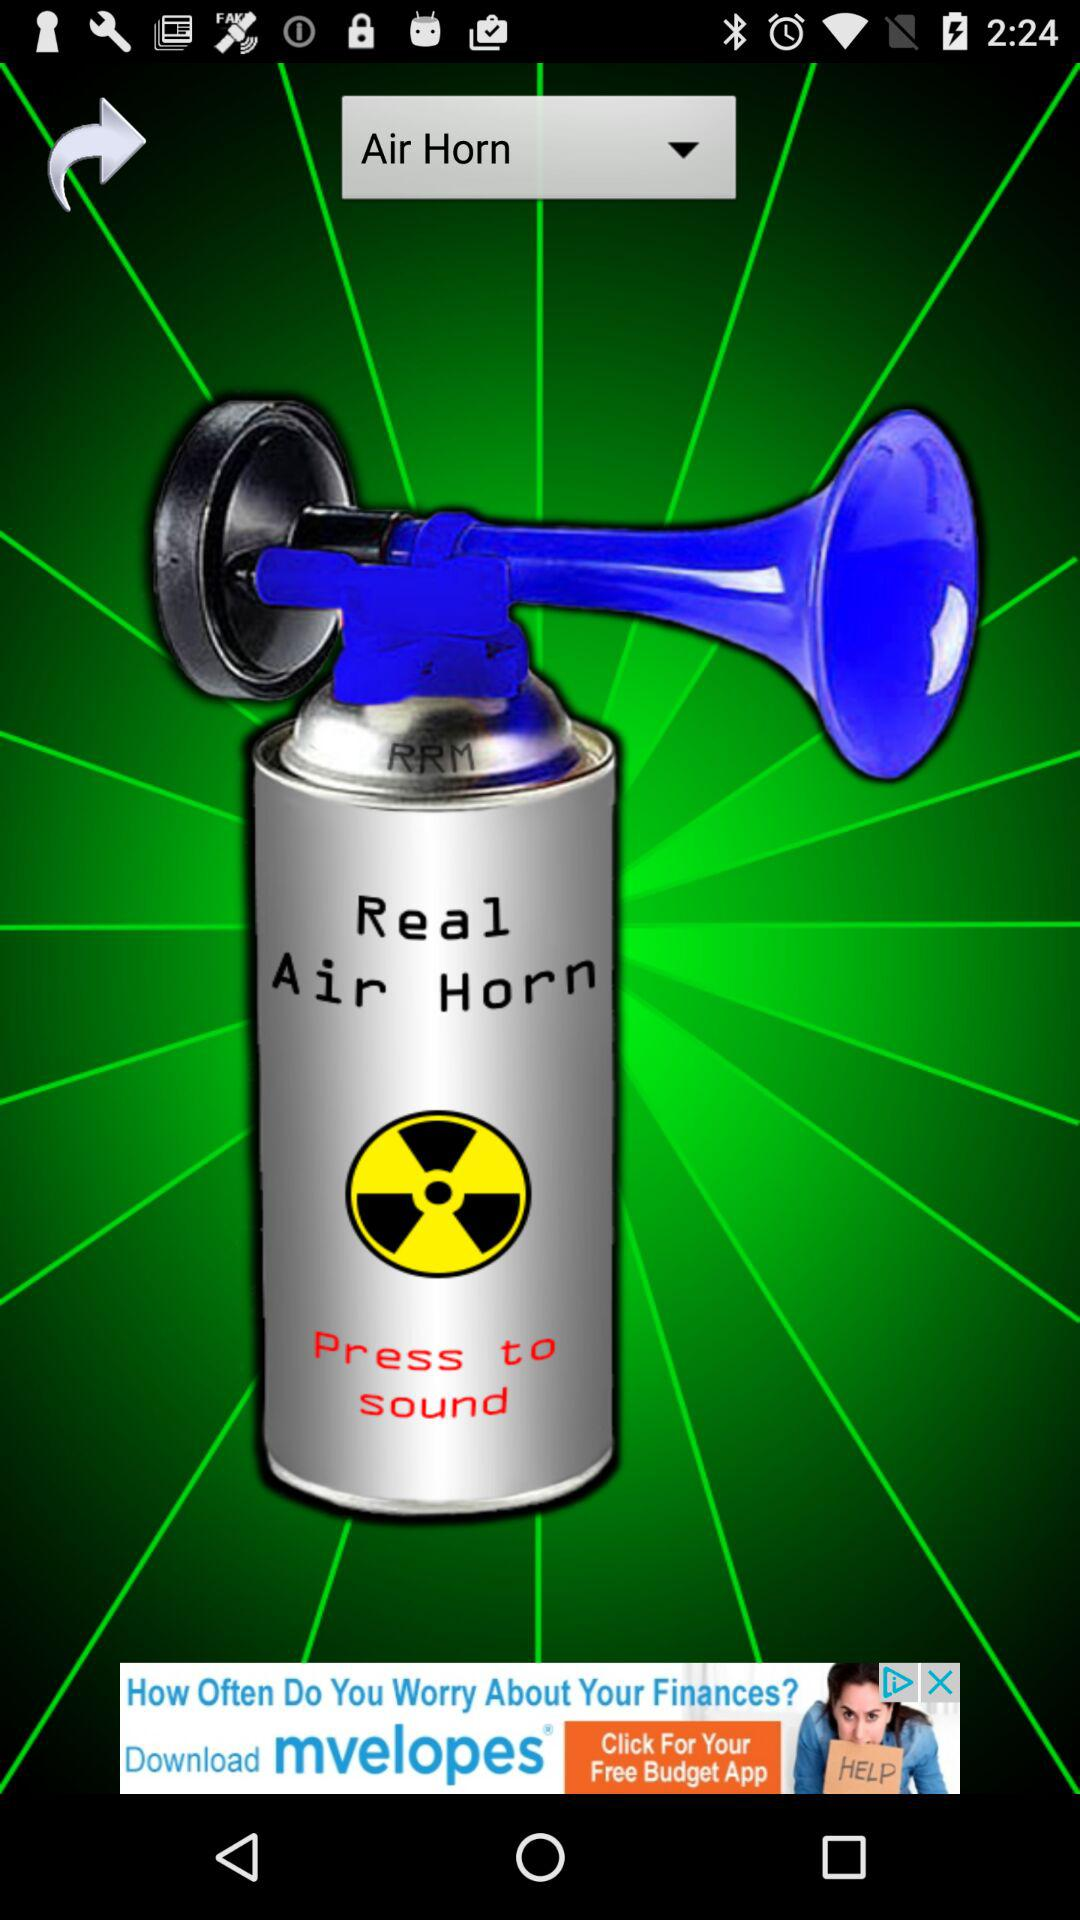What is the name of the application? The name of the application is "Air Horn Prank". 